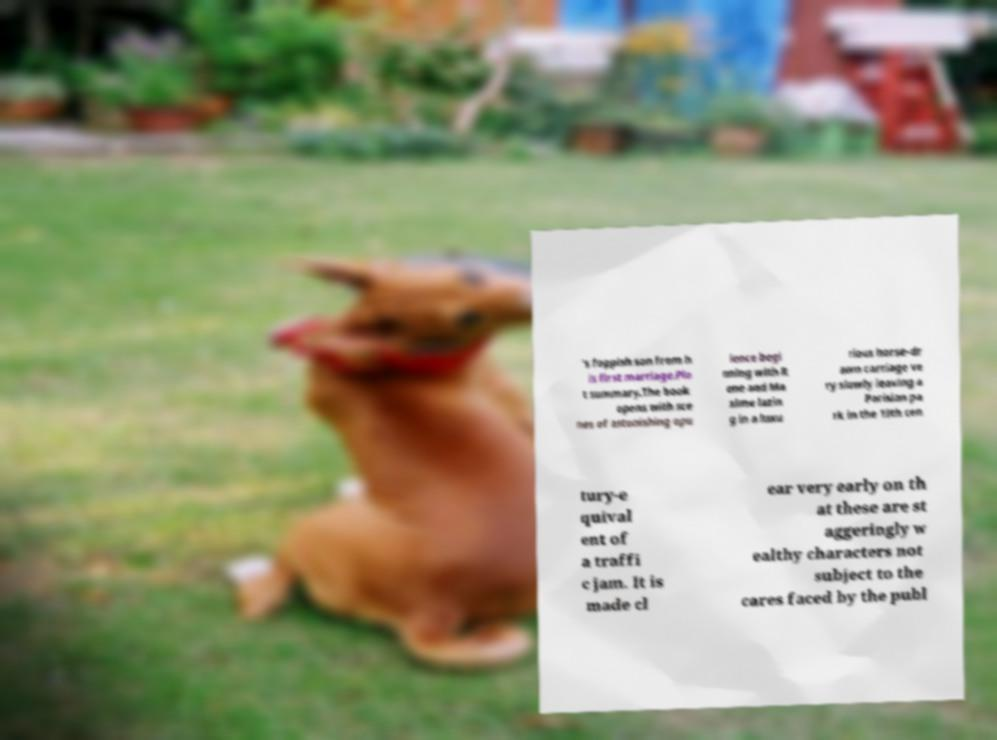Please read and relay the text visible in this image. What does it say? 's foppish son from h is first marriage.Plo t summary.The book opens with sce nes of astonishing opu lence begi nning with R ene and Ma xime lazin g in a luxu rious horse-dr awn carriage ve ry slowly leaving a Parisian pa rk in the 19th cen tury-e quival ent of a traffi c jam. It is made cl ear very early on th at these are st aggeringly w ealthy characters not subject to the cares faced by the publ 